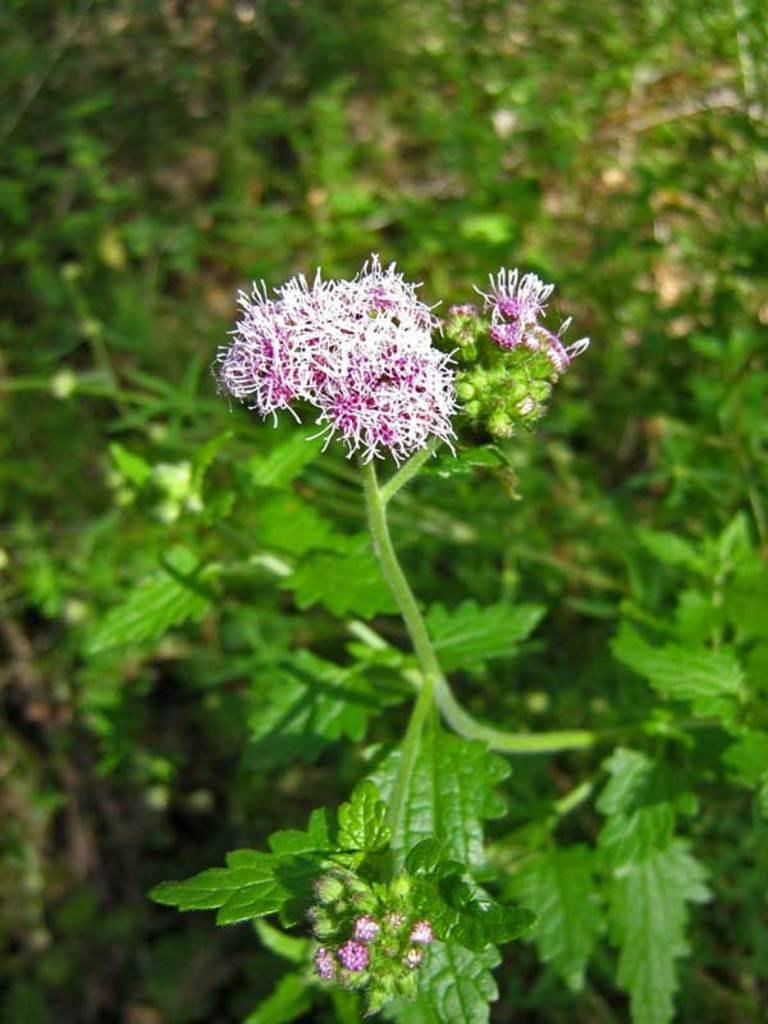Can you describe this image briefly? In this image I can see a flower. In the background, I can see the plants. 